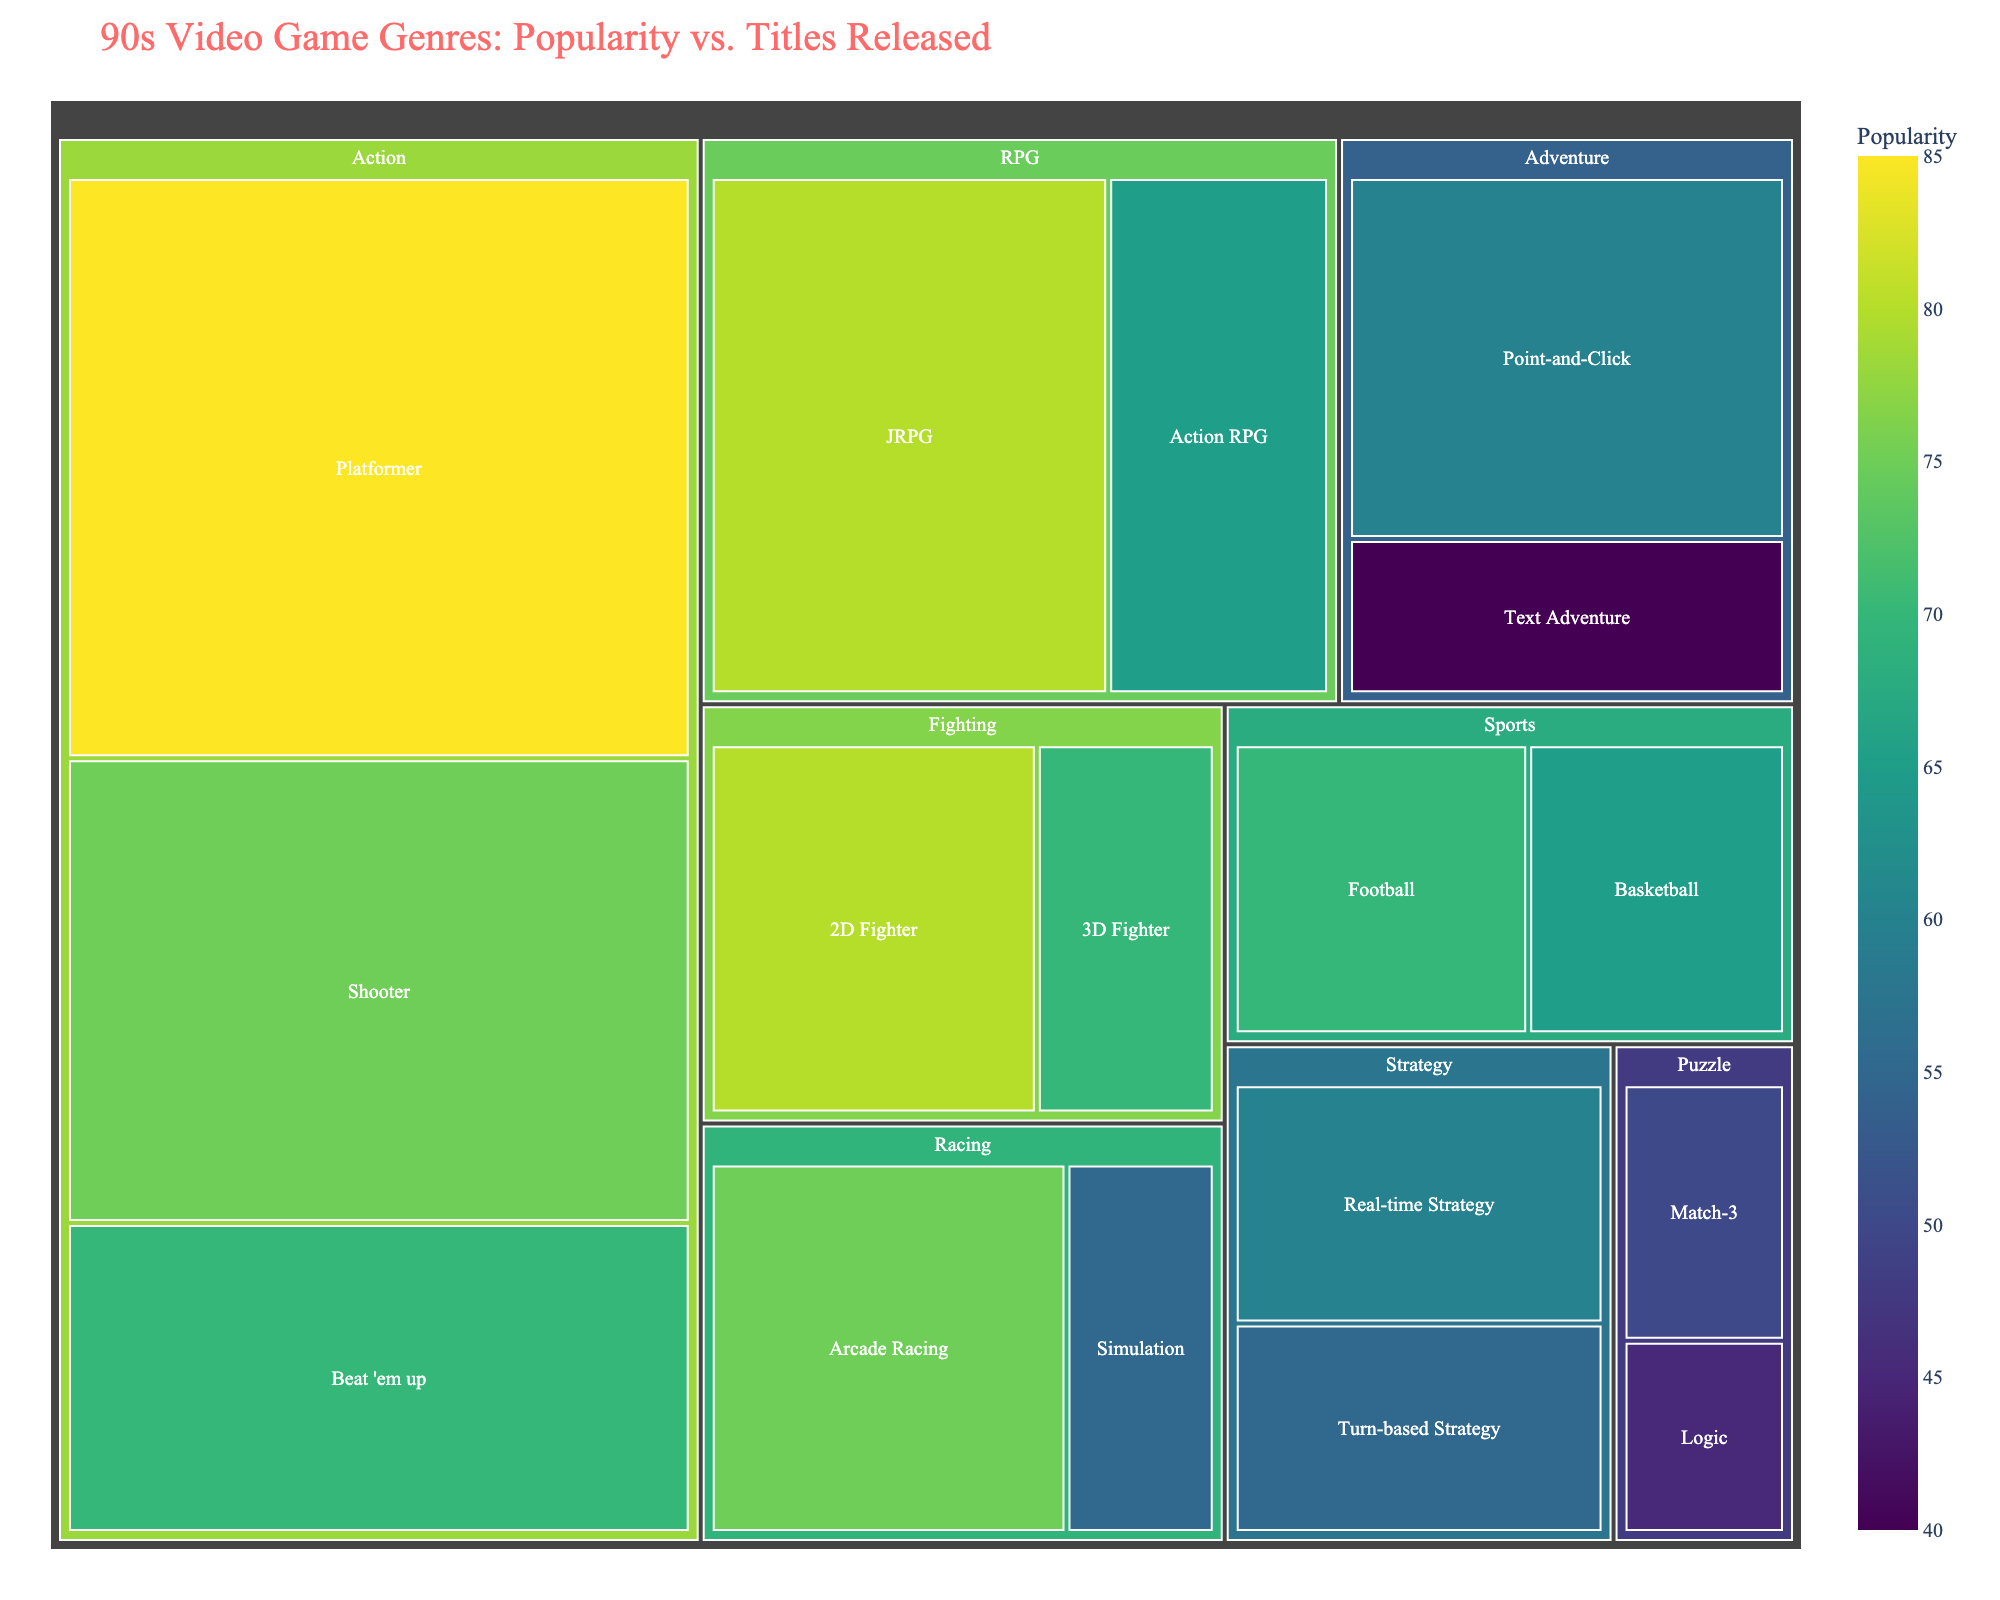What's the title of the treemap figure? The title of the figure is usually found at the top and is meant to describe what the data visualization represents. In this case, the title helps to clarify that the figure is a treemap showing the popularity and number of titles released for 90s video game genres.
Answer: 90s Video Game Genres: Popularity vs. Titles Released Which subgenre has the highest popularity in the Action genre? To find the subgenre with the highest popularity in the Action genre, look for the subgenres listed under Action and compare their popularity values. The one with the highest number is the answer.
Answer: Platformer How many titles have been released in the RPG genre in total? Summing up the titles of all subgenres within the RPG genre gives the total. JRPG has 90 and Action RPG has 50. Adding these gives the total.
Answer: 140 What is the color scheme used to represent popularity? The color scheme for popularity in the treemap is described in the code where "Viridis" is mentioned as the color scale. This generally means a gradient from dark purple to yellow.
Answer: Viridis Which genre has the highest total number of titles released? To find this, sum up the titles of all subgenres within each genre and compare the totals. Action has 150 + 80 + 120 = 350 titles, which is the highest.
Answer: Action How does the popularity of Real-time Strategy compare to Turn-based Strategy? Real-time Strategy has a popularity of 60, while Turn-based Strategy has a popularity of 55. To compare them, 60 (Real-time Strategy) > 55 (Turn-based Strategy).
Answer: Real-time Strategy is more popular What is the most common subgenre within the Fighting genre based on the number of titles released? Look for the Fighting genre and compare the number of titles released for its subgenres. 2D Fighter has 55 titles and 3D Fighter has 30 titles.
Answer: 2D Fighter What is the average popularity across all subgenres in the Sports genre? Calculate the average by summing the popularities of the subgenres within Sports and then dividing by the number of subgenres. Popularities are 70 (Football) and 65 (Basketball), and the average is (70 + 65) / 2.
Answer: 67.5 Which subgenre in the Puzzle genre has fewer titles released, Match-3 or Logic? Compare the number of titles released for Match-3 and Logic. Match-3 has 20 and Logic has 15.
Answer: Logic What are the three least popular subgenres in the treemap? To find the least popular subgenres, look at the popularity values and identify the three lowest numbers. These are Text Adventure (40), Logic (45), and Match-3 (50).
Answer: Text Adventure, Logic, Match-3 